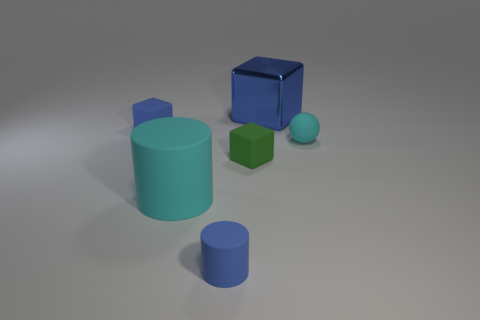What number of brown objects are cylinders or tiny things?
Your answer should be very brief. 0. Do the blue matte thing that is in front of the cyan matte sphere and the small cyan object have the same shape?
Your response must be concise. No. Is the number of rubber cylinders that are behind the cyan matte ball greater than the number of cyan metallic spheres?
Your answer should be compact. No. What number of things are the same size as the blue shiny block?
Give a very brief answer. 1. What is the size of the metallic cube that is the same color as the small matte cylinder?
Provide a short and direct response. Large. What number of objects are blue blocks or blocks that are left of the large blue metallic block?
Give a very brief answer. 3. What is the color of the rubber object that is both to the left of the green rubber block and behind the cyan cylinder?
Offer a very short reply. Blue. Is the size of the metal block the same as the green cube?
Give a very brief answer. No. What color is the big object that is behind the large cyan thing?
Ensure brevity in your answer.  Blue. Is there another big matte cylinder of the same color as the big cylinder?
Offer a terse response. No. 